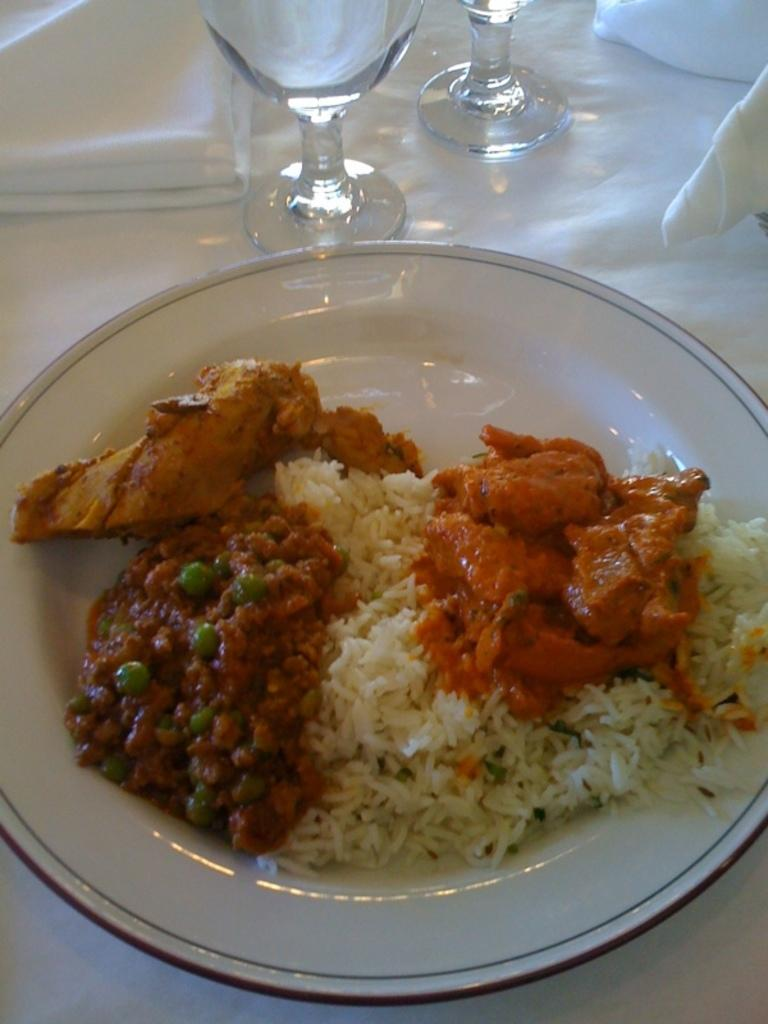What is on the plate that is visible in the image? There is food on a plate in the image. What is the primary object on the table in the image? There is a plate in the image. What type of containers are present in the image? There are glasses in the image. What can be used for wiping or blowing one's nose in the image? Tissues are present in the image. What color is the tablecloth covering the table in the image? The table is covered with a white cloth. What is the desire of the food on the plate in the image? Food does not have desires; it is an inanimate object. 